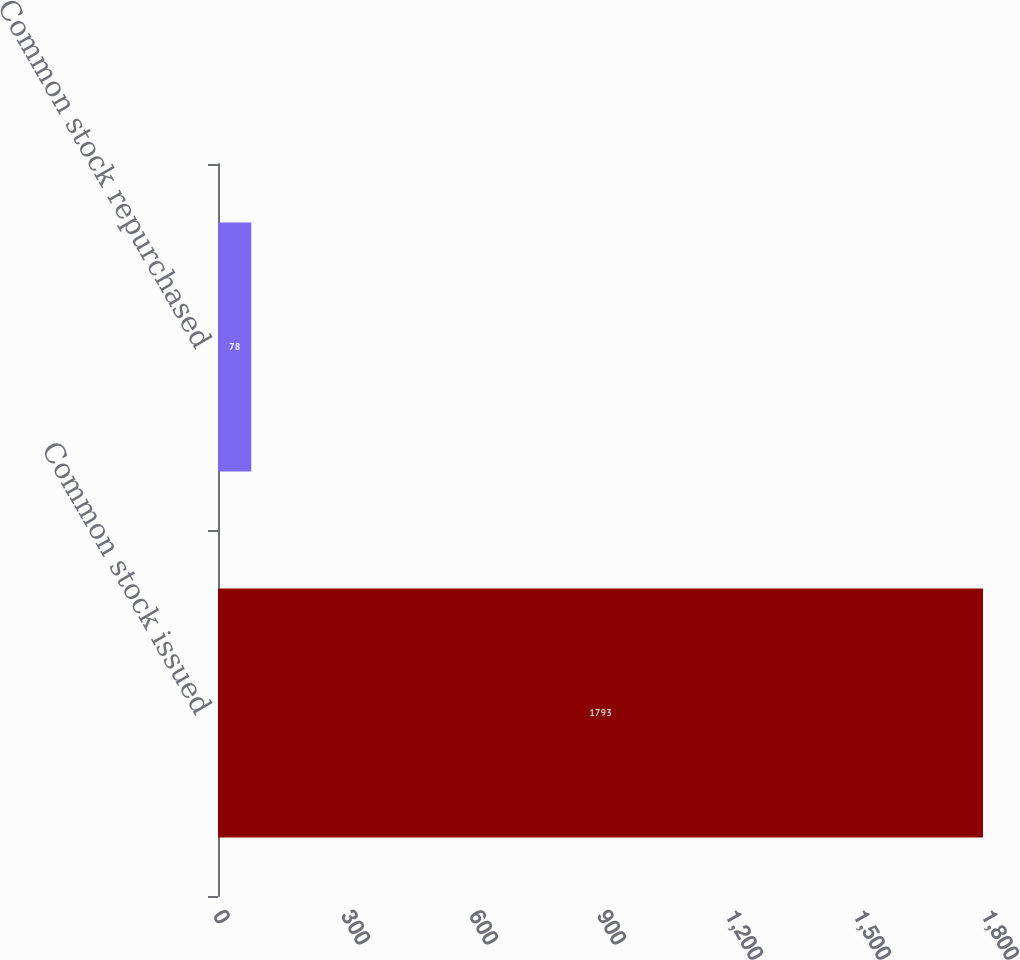Convert chart. <chart><loc_0><loc_0><loc_500><loc_500><bar_chart><fcel>Common stock issued<fcel>Common stock repurchased<nl><fcel>1793<fcel>78<nl></chart> 